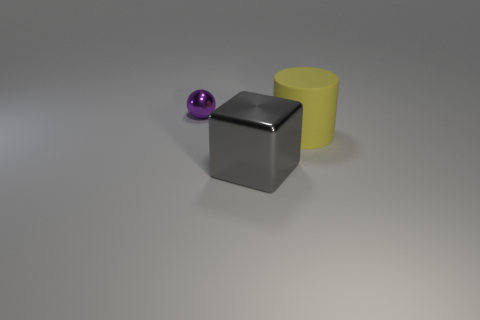What number of balls have the same material as the gray block?
Provide a short and direct response. 1. Is there a gray metallic object that has the same shape as the yellow rubber object?
Ensure brevity in your answer.  No. There is a gray object that is the same size as the rubber cylinder; what shape is it?
Offer a terse response. Cube. There is a shiny ball; is it the same color as the metal object that is in front of the purple metal thing?
Give a very brief answer. No. What number of matte objects are in front of the shiny object in front of the ball?
Your answer should be very brief. 0. There is a thing that is to the left of the yellow rubber cylinder and behind the large gray cube; what size is it?
Ensure brevity in your answer.  Small. Are there any other matte cylinders that have the same size as the matte cylinder?
Your answer should be compact. No. Are there more yellow cylinders in front of the big cylinder than cubes that are to the right of the small purple ball?
Your response must be concise. No. Do the small purple sphere and the large cylinder that is behind the big gray thing have the same material?
Give a very brief answer. No. What number of yellow objects are behind the shiny object that is left of the metal object that is in front of the tiny purple ball?
Provide a succinct answer. 0. 